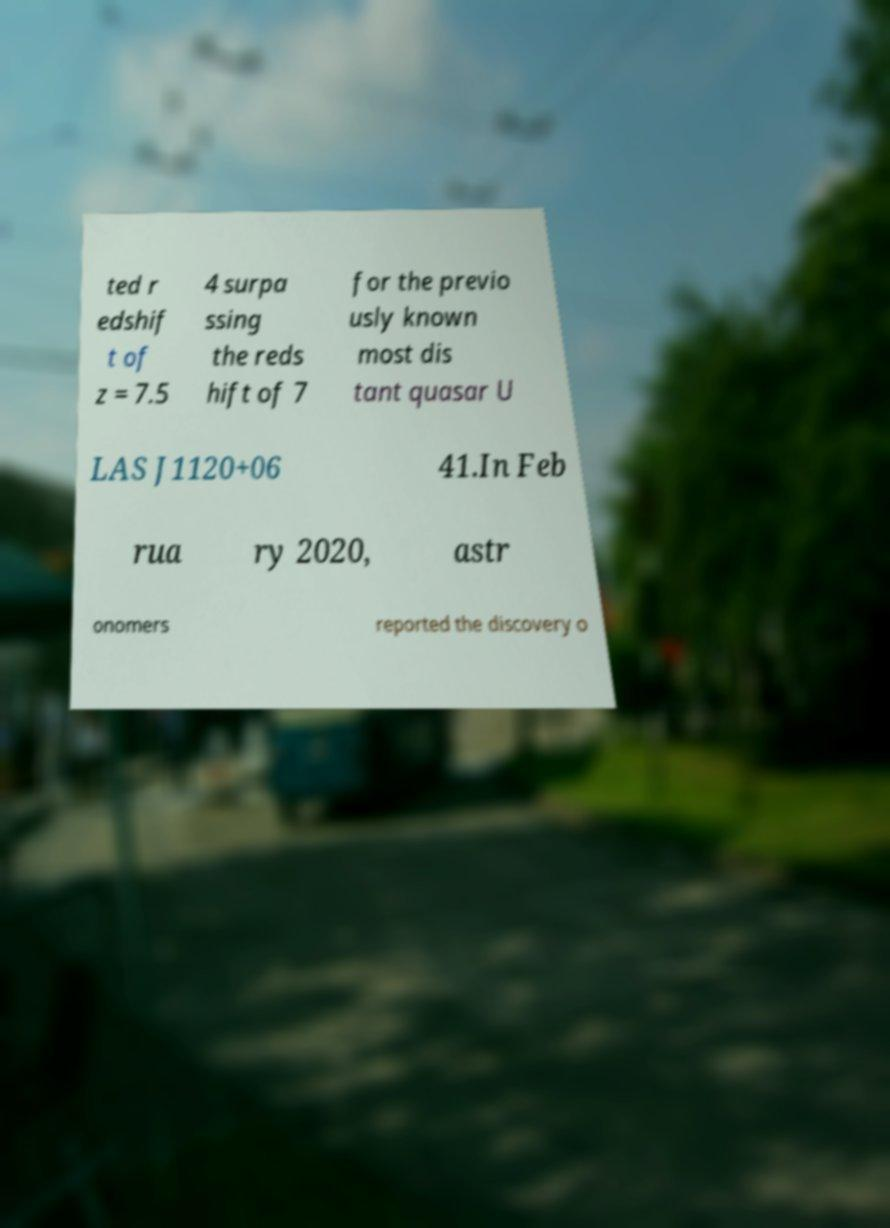Could you assist in decoding the text presented in this image and type it out clearly? ted r edshif t of z = 7.5 4 surpa ssing the reds hift of 7 for the previo usly known most dis tant quasar U LAS J1120+06 41.In Feb rua ry 2020, astr onomers reported the discovery o 